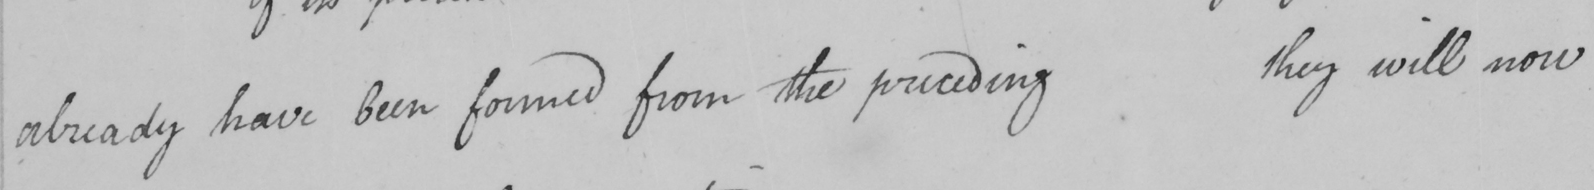What does this handwritten line say? already have been formed from the preceding they will now 